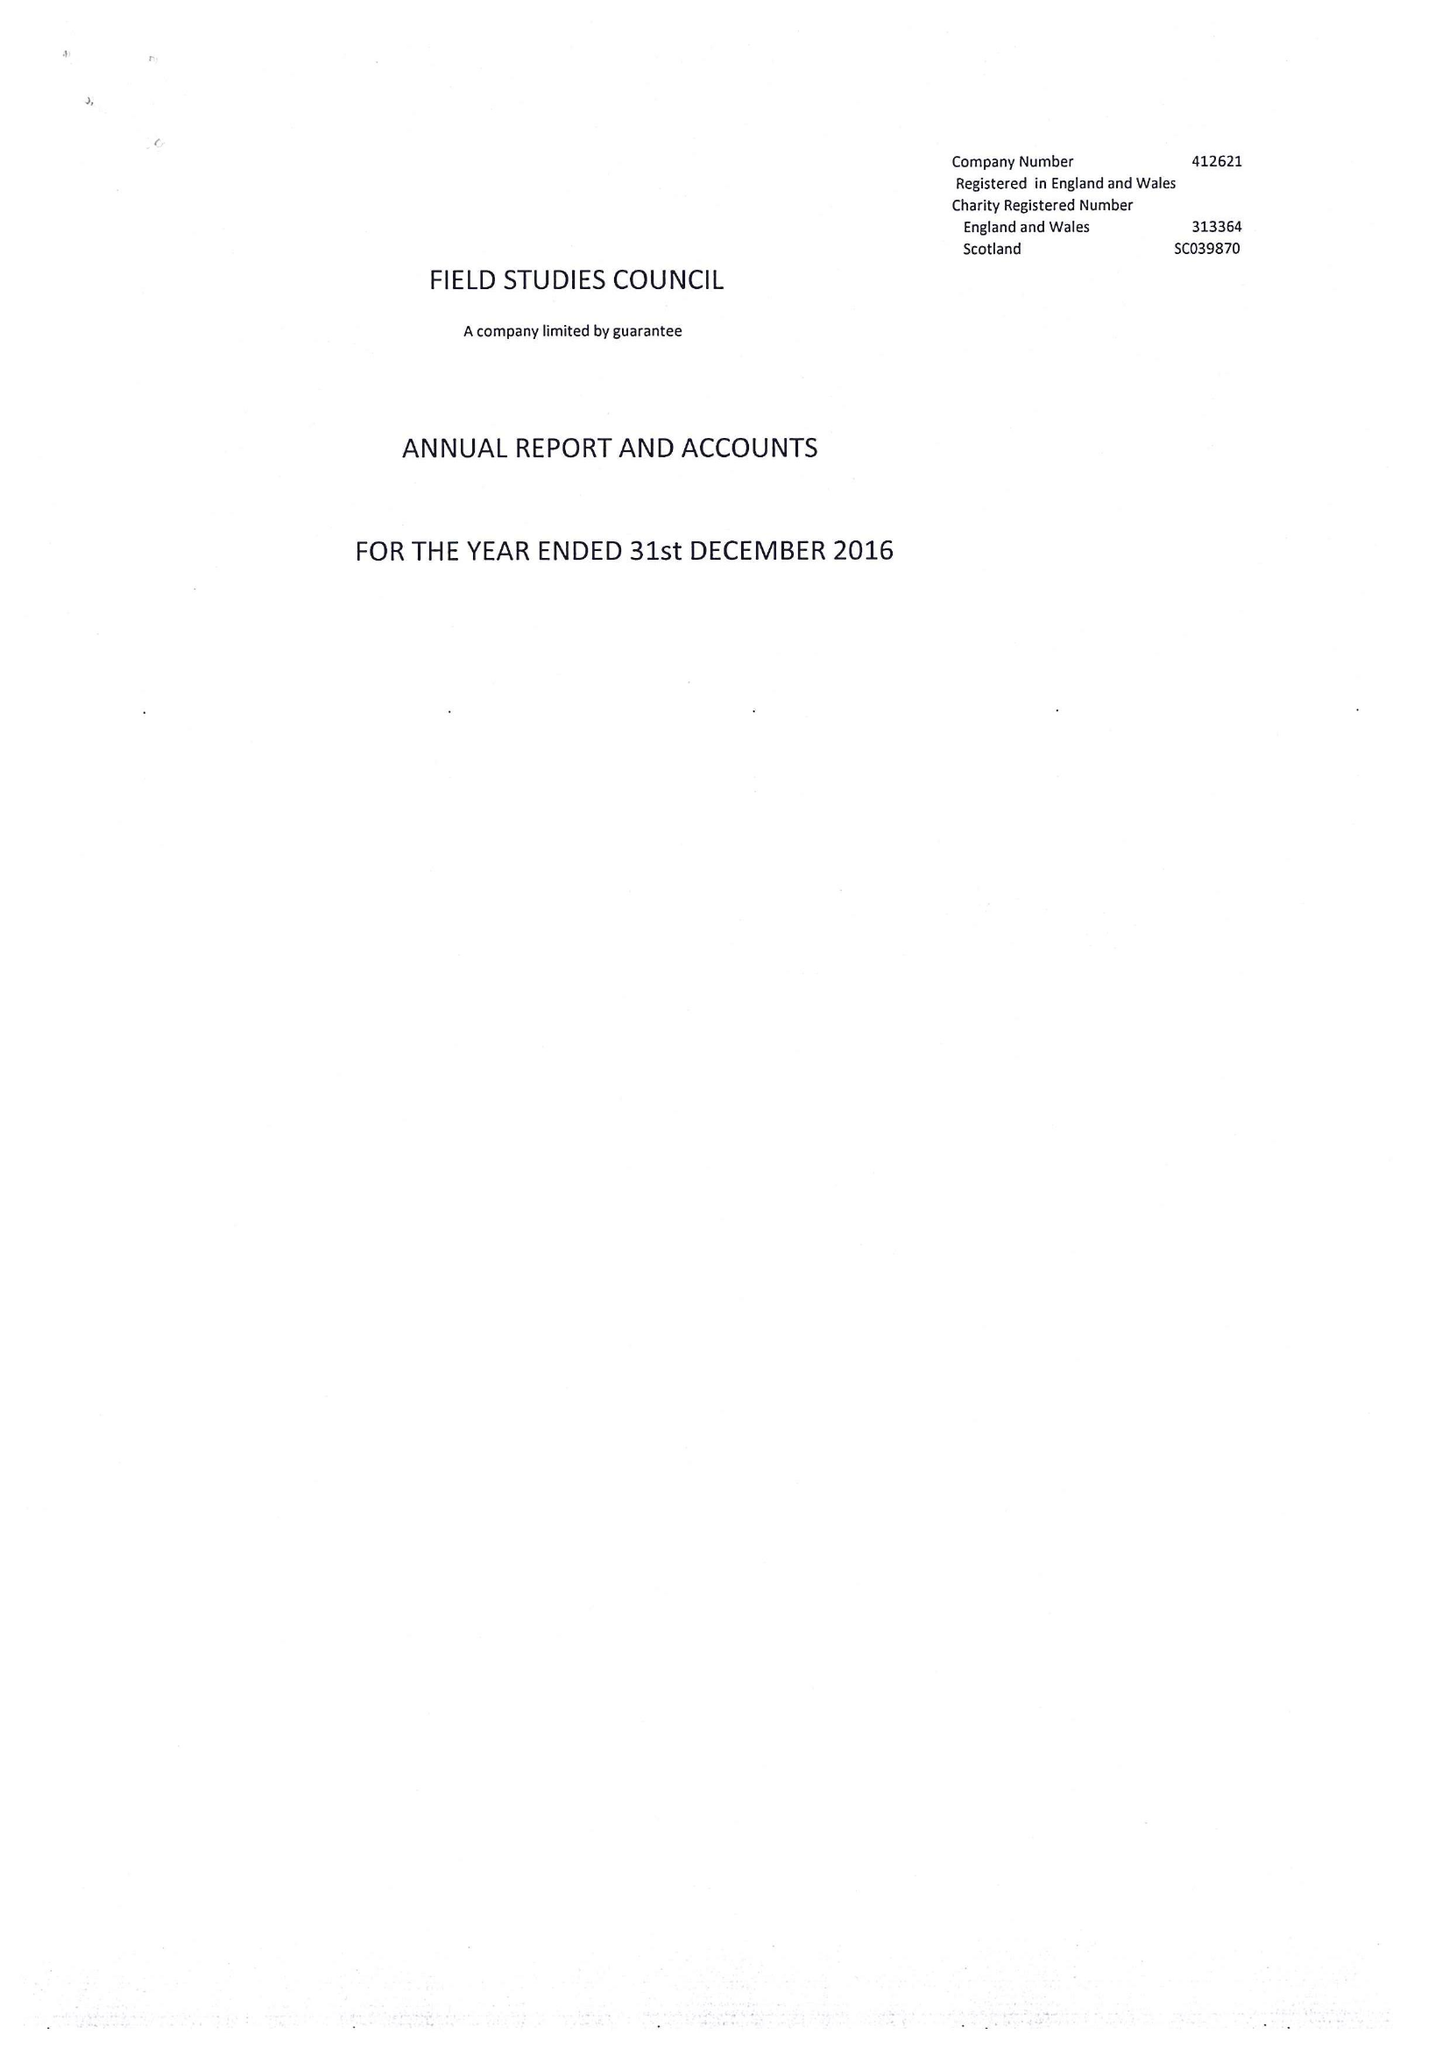What is the value for the charity_number?
Answer the question using a single word or phrase. 313364 